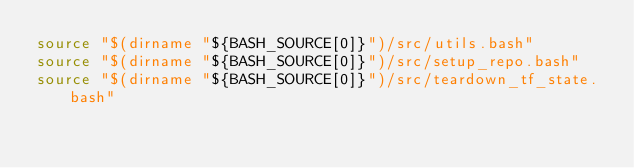Convert code to text. <code><loc_0><loc_0><loc_500><loc_500><_Bash_>source "$(dirname "${BASH_SOURCE[0]}")/src/utils.bash"
source "$(dirname "${BASH_SOURCE[0]}")/src/setup_repo.bash"
source "$(dirname "${BASH_SOURCE[0]}")/src/teardown_tf_state.bash"</code> 